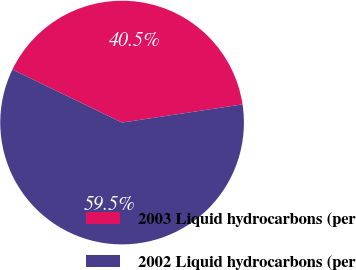<chart> <loc_0><loc_0><loc_500><loc_500><pie_chart><fcel>2003 Liquid hydrocarbons (per<fcel>2002 Liquid hydrocarbons (per<nl><fcel>40.45%<fcel>59.55%<nl></chart> 